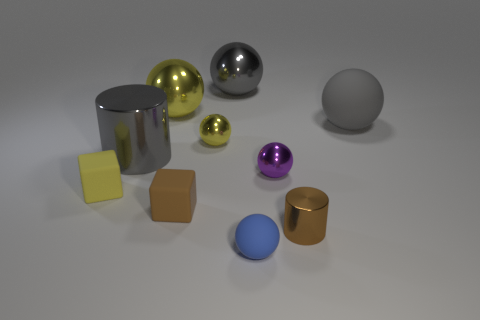There is a yellow thing that is right of the brown matte block; what size is it?
Give a very brief answer. Small. There is a cylinder that is to the left of the small yellow metallic ball; what is it made of?
Give a very brief answer. Metal. How many red objects are tiny matte balls or balls?
Make the answer very short. 0. Is the tiny brown block made of the same material as the purple object that is behind the small brown cylinder?
Give a very brief answer. No. Are there the same number of tiny blue balls that are behind the small brown cylinder and large metal spheres that are on the right side of the gray metal ball?
Provide a short and direct response. Yes. There is a gray rubber ball; is its size the same as the metal cylinder that is in front of the large gray metal cylinder?
Offer a very short reply. No. Are there more purple things behind the gray metal ball than yellow shiny objects?
Offer a very short reply. No. What number of blue shiny cubes are the same size as the purple sphere?
Provide a short and direct response. 0. There is a yellow shiny ball on the right side of the brown cube; is it the same size as the matte thing that is in front of the small brown metallic cylinder?
Make the answer very short. Yes. Is the number of tiny blue rubber objects that are behind the small brown matte block greater than the number of brown metal cylinders right of the gray rubber object?
Provide a succinct answer. No. 